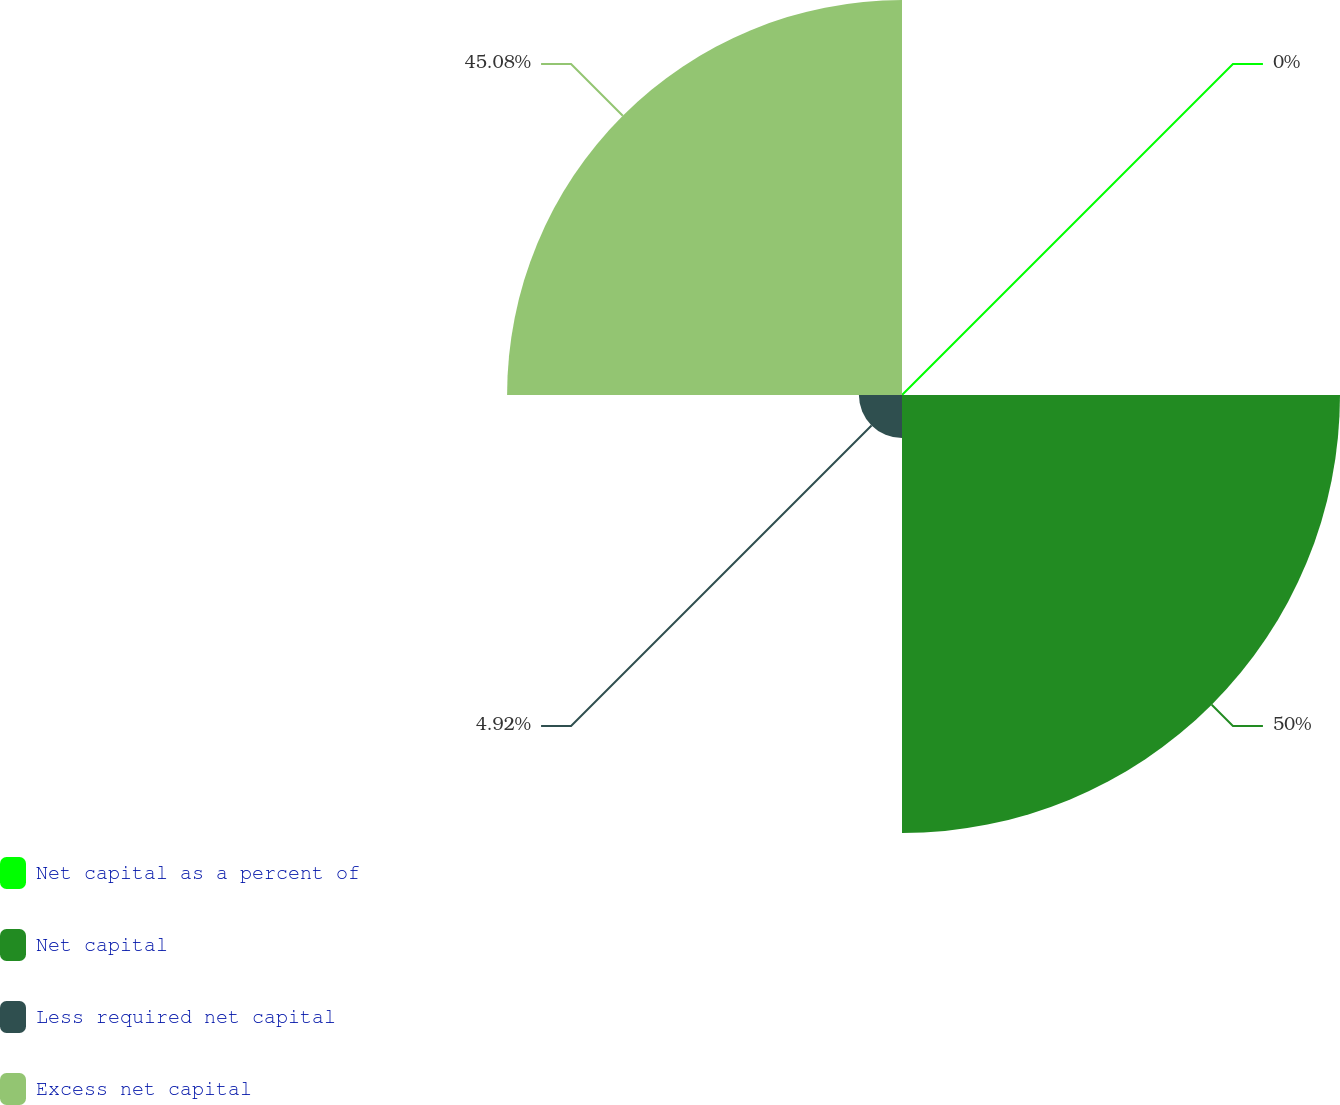<chart> <loc_0><loc_0><loc_500><loc_500><pie_chart><fcel>Net capital as a percent of<fcel>Net capital<fcel>Less required net capital<fcel>Excess net capital<nl><fcel>0.0%<fcel>50.0%<fcel>4.92%<fcel>45.08%<nl></chart> 